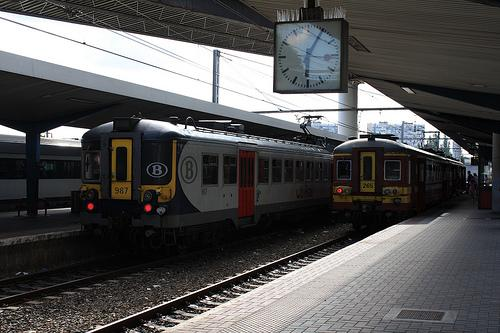Highlight any timekeeping element present within the image. A white clock with black numbers and black hands is visible in the scene, with the red second hand and glazed glass. Talk about the distinctive color schemes present for the objects in the image. A white, black, and yellow train with red and yellow doors is depicted, along with a red and black trash can on the platform. Talk about any patterns or surfaces depicted in the image, along with any associated objects. The image features gravel in between train tracks, a brick walkway at the station, and a gutter in the street. Describe the various types of lighting elements or features present in the image. There are red lights on the train, a red and black trash can, and a light in the roof of the building in the scene. Examine any architectural details and human activity in the image. People are boarding the train at a station platform surrounded by tall buildings, a sewer grate, a clock, and several designs on the train. Mention the primary mode of transportation visible in the image and the activity taking place around it. A train is stopped at a platform with people boarding it and various trains, doors, and lights visible in the scene. Describe the most eye-catching feature of the image and the objects around it. A train station platform bustles with activity, featuring a colorful train with red and yellow doors, and nearby sewer grate. Describe the overall atmosphere and setting of the image, focusing on its location and elements. The image captures a busy train station platform with various trains, doors, lights, and surrounding structures like buildings and a clock. Discuss any structural aspects of the image, and mention the elements present in the background. The image shows a train station platform with tall buildings in the background, wires on the pole, and a post holding up a roof. Mention any numbers or text visible on the objects in the image. The image showcases numbers 265, 987 on the train, a white letter on the train, a "B" logo, and black numbers on a white clock. 